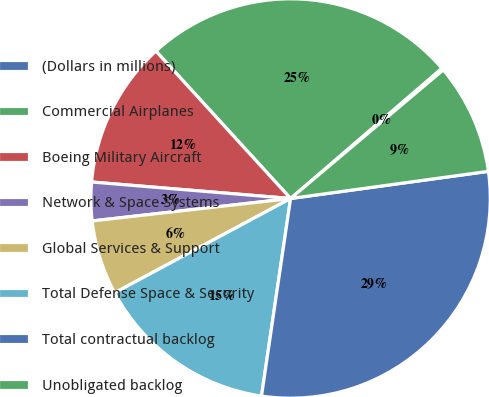Convert chart to OTSL. <chart><loc_0><loc_0><loc_500><loc_500><pie_chart><fcel>(Dollars in millions)<fcel>Commercial Airplanes<fcel>Boeing Military Aircraft<fcel>Network & Space Systems<fcel>Global Services & Support<fcel>Total Defense Space & Security<fcel>Total contractual backlog<fcel>Unobligated backlog<nl><fcel>0.17%<fcel>25.47%<fcel>11.9%<fcel>3.11%<fcel>6.04%<fcel>14.84%<fcel>29.5%<fcel>8.97%<nl></chart> 